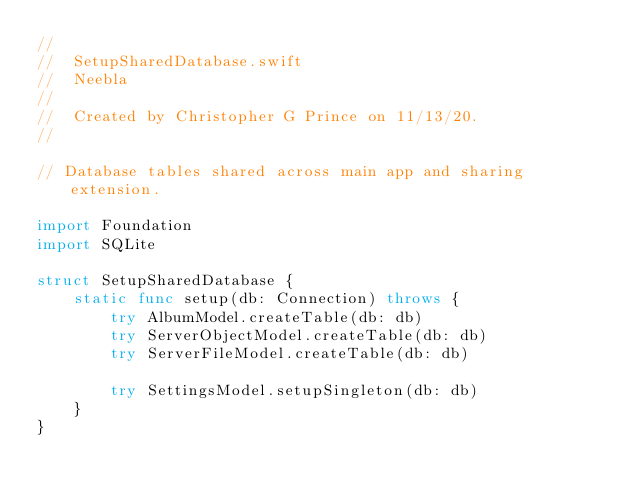Convert code to text. <code><loc_0><loc_0><loc_500><loc_500><_Swift_>//
//  SetupSharedDatabase.swift
//  Neebla
//
//  Created by Christopher G Prince on 11/13/20.
//

// Database tables shared across main app and sharing extension.

import Foundation
import SQLite

struct SetupSharedDatabase {
    static func setup(db: Connection) throws {
        try AlbumModel.createTable(db: db)
        try ServerObjectModel.createTable(db: db)
        try ServerFileModel.createTable(db: db)
        
        try SettingsModel.setupSingleton(db: db)
    }
}
</code> 